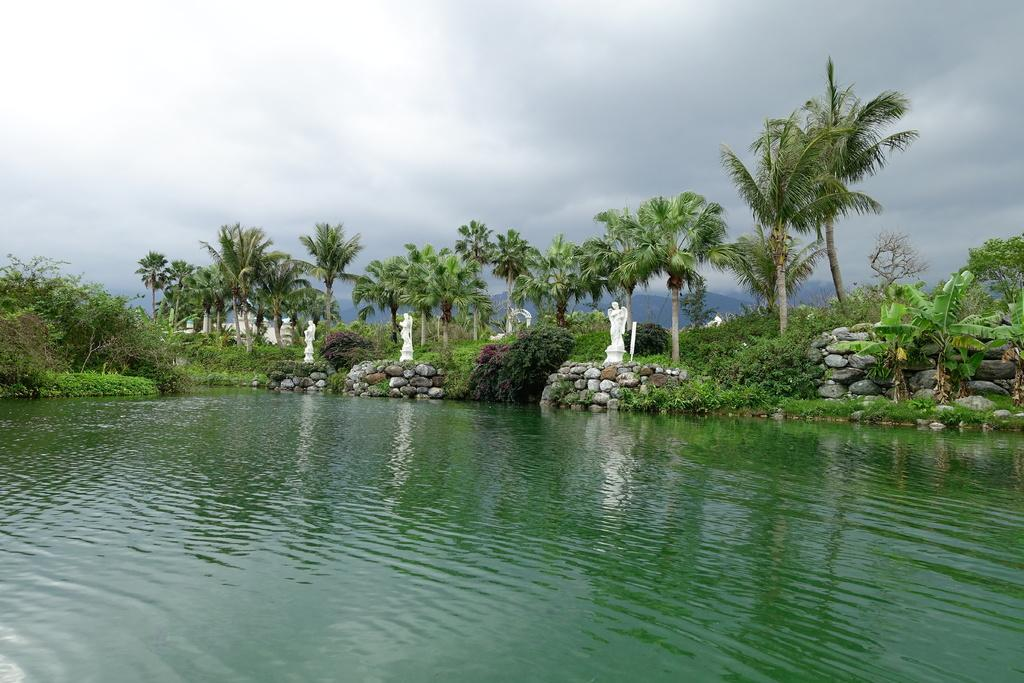What type of natural elements can be seen in the image? There are trees in the image. What man-made structures are present in the image? There are statues and a building in the image. What is visible at the top of the image? The sky is visible at the top of the image, and there are clouds in the sky. What type of terrain is visible at the bottom of the image? There is water visible at the bottom of the image. How many fifths are present in the image? There is no reference to a "fifth" in the image, so it is not possible to answer that question. Is there a volcano visible in the image? No, there is no volcano present in the image. Can you describe the parcel that is being delivered in the image? There is no parcel being delivered in the image; it features trees, statues, a building, the sky, clouds, and water. 